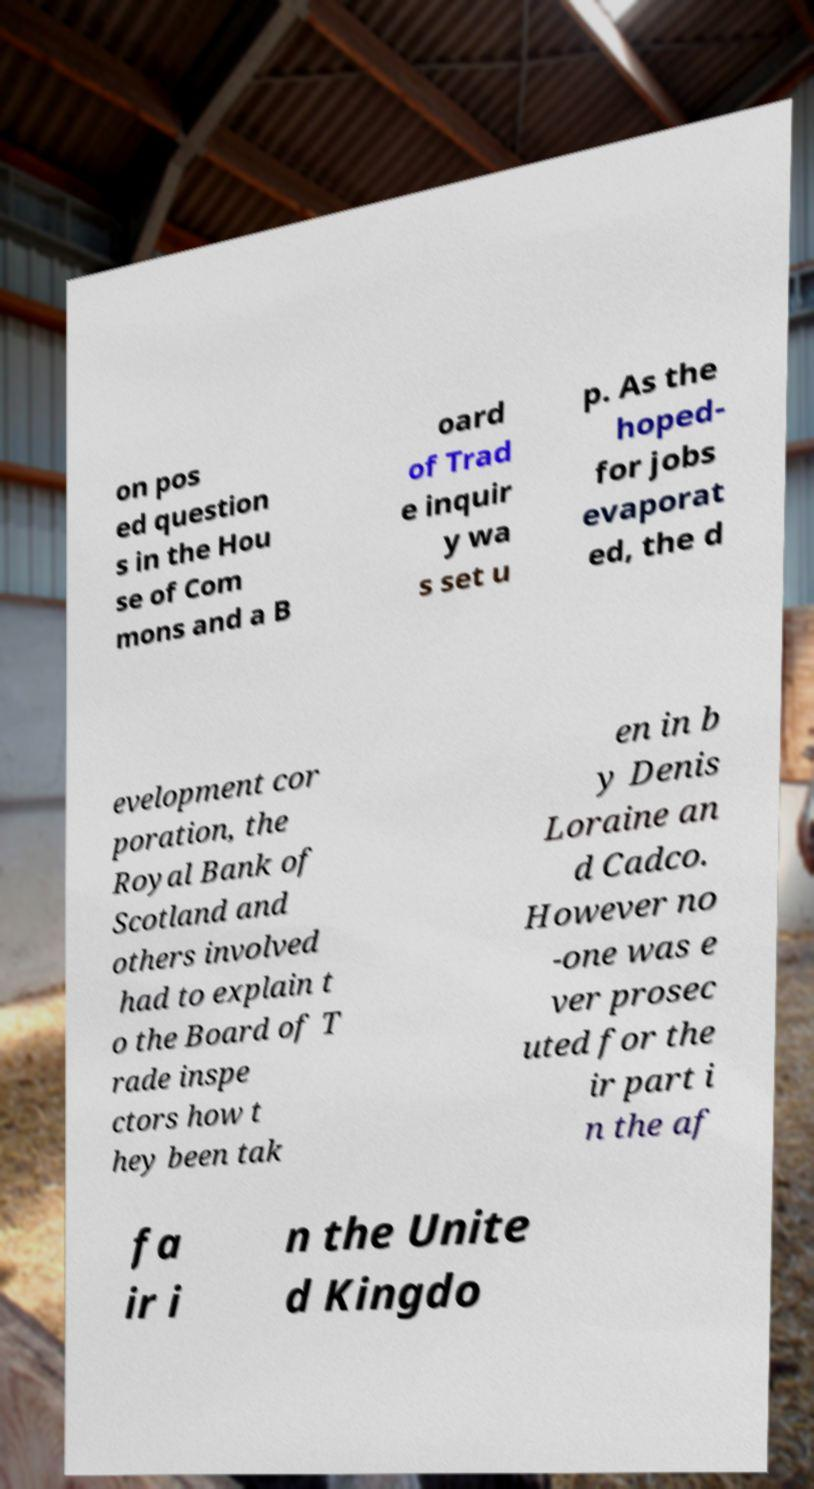Can you read and provide the text displayed in the image?This photo seems to have some interesting text. Can you extract and type it out for me? on pos ed question s in the Hou se of Com mons and a B oard of Trad e inquir y wa s set u p. As the hoped- for jobs evaporat ed, the d evelopment cor poration, the Royal Bank of Scotland and others involved had to explain t o the Board of T rade inspe ctors how t hey been tak en in b y Denis Loraine an d Cadco. However no -one was e ver prosec uted for the ir part i n the af fa ir i n the Unite d Kingdo 